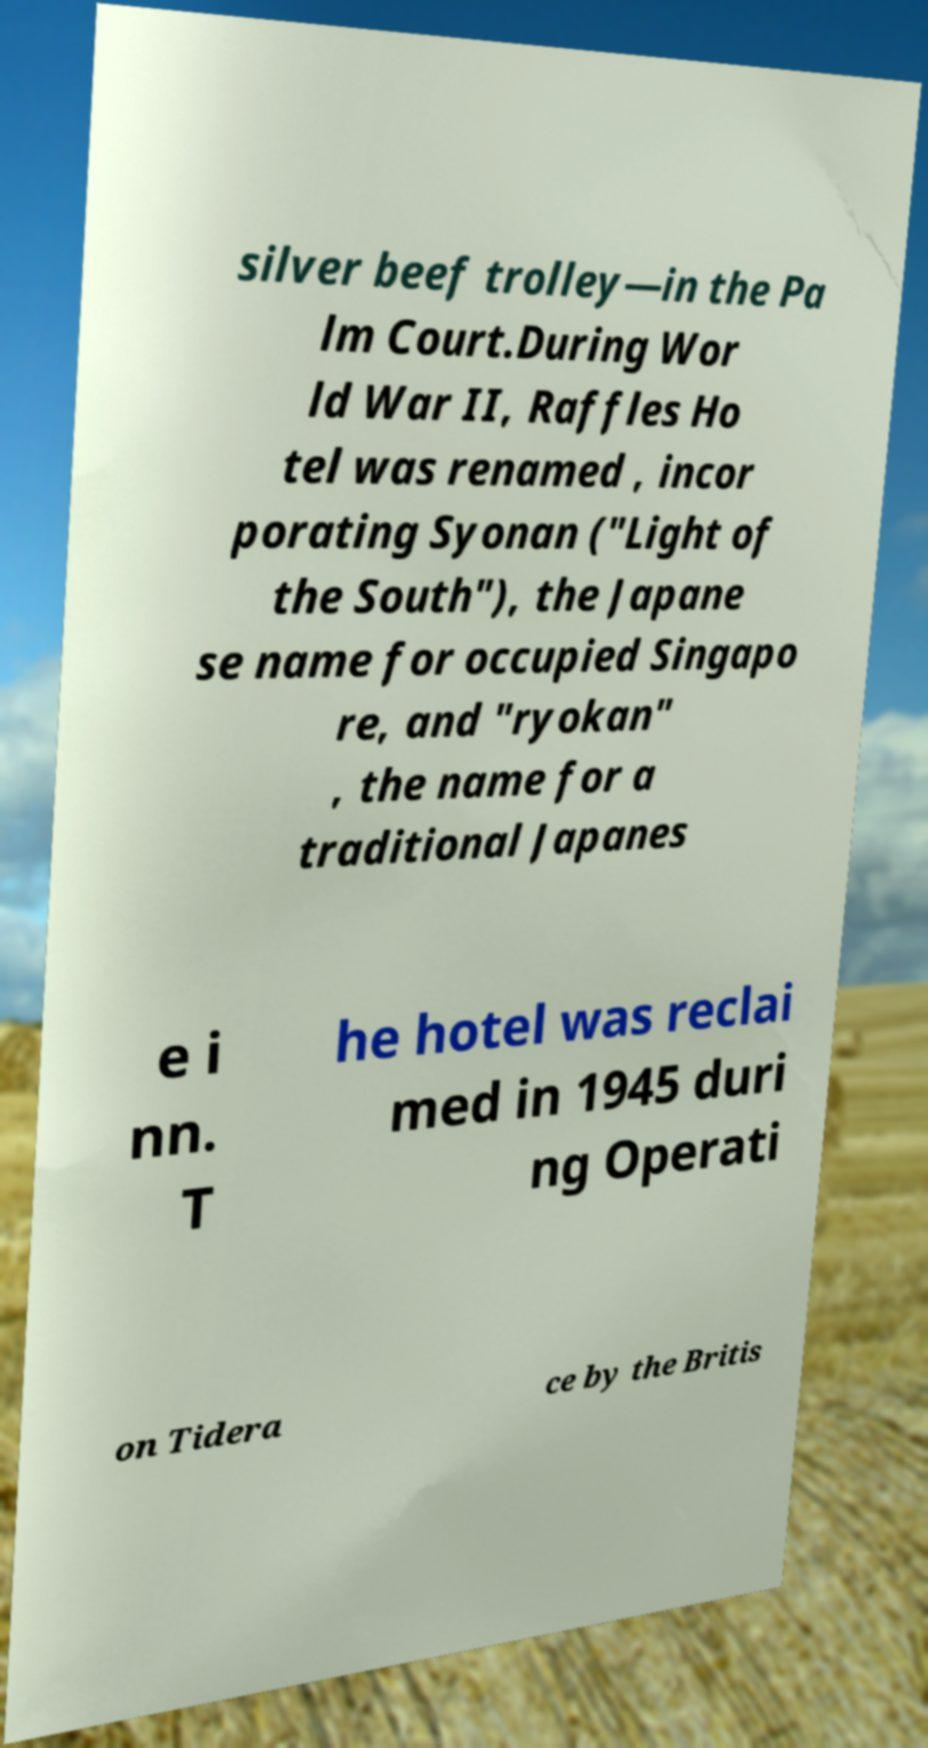Can you read and provide the text displayed in the image?This photo seems to have some interesting text. Can you extract and type it out for me? silver beef trolley—in the Pa lm Court.During Wor ld War II, Raffles Ho tel was renamed , incor porating Syonan ("Light of the South"), the Japane se name for occupied Singapo re, and "ryokan" , the name for a traditional Japanes e i nn. T he hotel was reclai med in 1945 duri ng Operati on Tidera ce by the Britis 